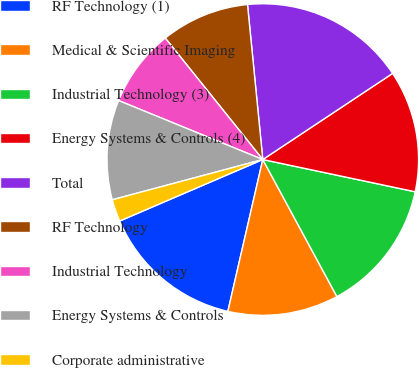Convert chart to OTSL. <chart><loc_0><loc_0><loc_500><loc_500><pie_chart><fcel>RF Technology (1)<fcel>Medical & Scientific Imaging<fcel>Industrial Technology (3)<fcel>Energy Systems & Controls (4)<fcel>Total<fcel>RF Technology<fcel>Industrial Technology<fcel>Energy Systems & Controls<fcel>Corporate administrative<nl><fcel>14.94%<fcel>11.49%<fcel>13.79%<fcel>12.64%<fcel>17.24%<fcel>9.2%<fcel>8.05%<fcel>10.34%<fcel>2.3%<nl></chart> 